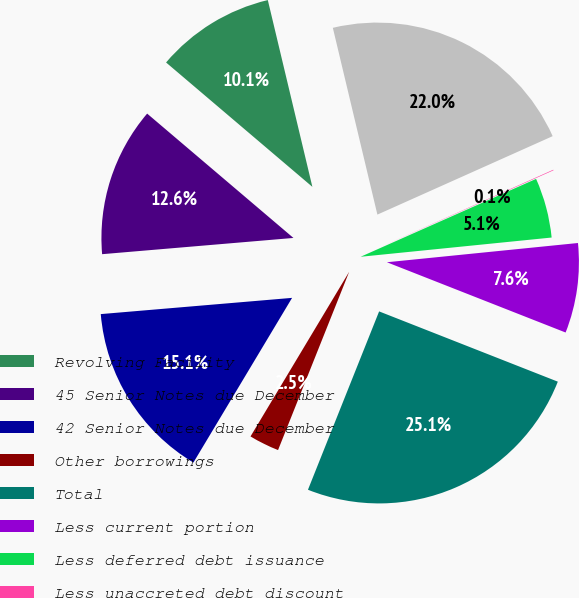Convert chart. <chart><loc_0><loc_0><loc_500><loc_500><pie_chart><fcel>Revolving Facility<fcel>45 Senior Notes due December<fcel>42 Senior Notes due December<fcel>Other borrowings<fcel>Total<fcel>Less current portion<fcel>Less deferred debt issuance<fcel>Less unaccreted debt discount<fcel>Total long-term borrowings<nl><fcel>10.06%<fcel>12.56%<fcel>15.06%<fcel>2.55%<fcel>25.08%<fcel>7.56%<fcel>5.05%<fcel>0.05%<fcel>22.03%<nl></chart> 